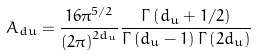Convert formula to latex. <formula><loc_0><loc_0><loc_500><loc_500>A _ { d u } = \frac { { 1 6 \pi ^ { 5 / 2 } } } { { \left ( { 2 \pi } \right ) ^ { 2 d _ { u } } } } \frac { { \Gamma \left ( { d _ { u } + 1 / 2 } \right ) } } { { \Gamma \left ( { d _ { u } - 1 } \right ) \Gamma \left ( { 2 d _ { u } } \right ) } }</formula> 